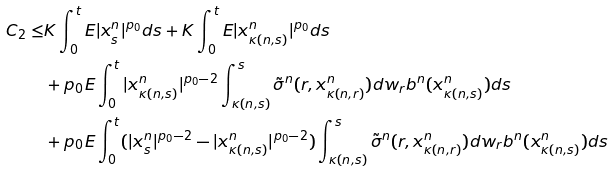<formula> <loc_0><loc_0><loc_500><loc_500>C _ { 2 } \leq & K \int _ { 0 } ^ { t } E | x _ { s } ^ { n } | ^ { p _ { 0 } } d s + K \int _ { 0 } ^ { t } E | x _ { \kappa ( n , s ) } ^ { n } | ^ { p _ { 0 } } d s \\ & + p _ { 0 } E \int _ { 0 } ^ { t } | x _ { \kappa ( n , s ) } ^ { n } | ^ { p _ { 0 } - 2 } \int ^ { s } _ { \kappa ( n , s ) } \tilde { \sigma } ^ { n } ( r , x _ { \kappa ( n , r ) } ^ { n } ) d w _ { r } b ^ { n } ( x _ { \kappa ( n , s ) } ^ { n } ) d s \\ & + p _ { 0 } E \int _ { 0 } ^ { t } ( | x _ { s } ^ { n } | ^ { p _ { 0 } - 2 } - | x _ { \kappa ( n , s ) } ^ { n } | ^ { p _ { 0 } - 2 } ) \int ^ { s } _ { \kappa ( n , s ) } \tilde { \sigma } ^ { n } ( r , x _ { \kappa ( n , r ) } ^ { n } ) d w _ { r } b ^ { n } ( x _ { \kappa ( n , s ) } ^ { n } ) d s</formula> 